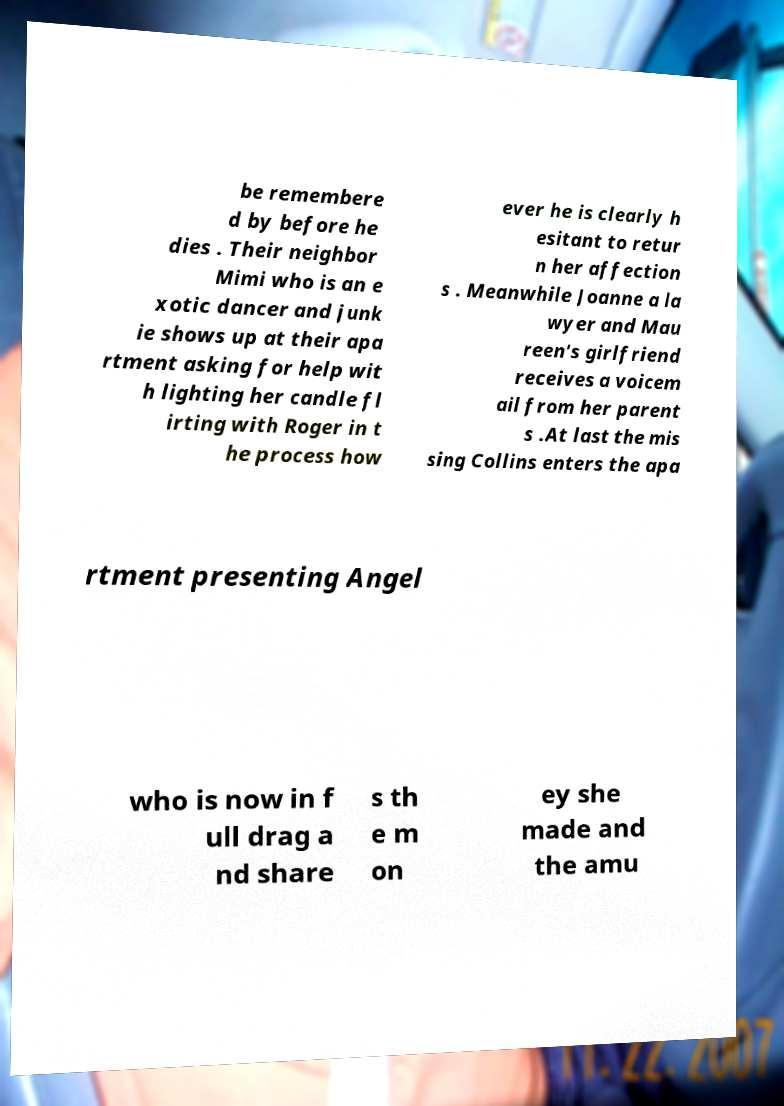For documentation purposes, I need the text within this image transcribed. Could you provide that? be remembere d by before he dies . Their neighbor Mimi who is an e xotic dancer and junk ie shows up at their apa rtment asking for help wit h lighting her candle fl irting with Roger in t he process how ever he is clearly h esitant to retur n her affection s . Meanwhile Joanne a la wyer and Mau reen's girlfriend receives a voicem ail from her parent s .At last the mis sing Collins enters the apa rtment presenting Angel who is now in f ull drag a nd share s th e m on ey she made and the amu 